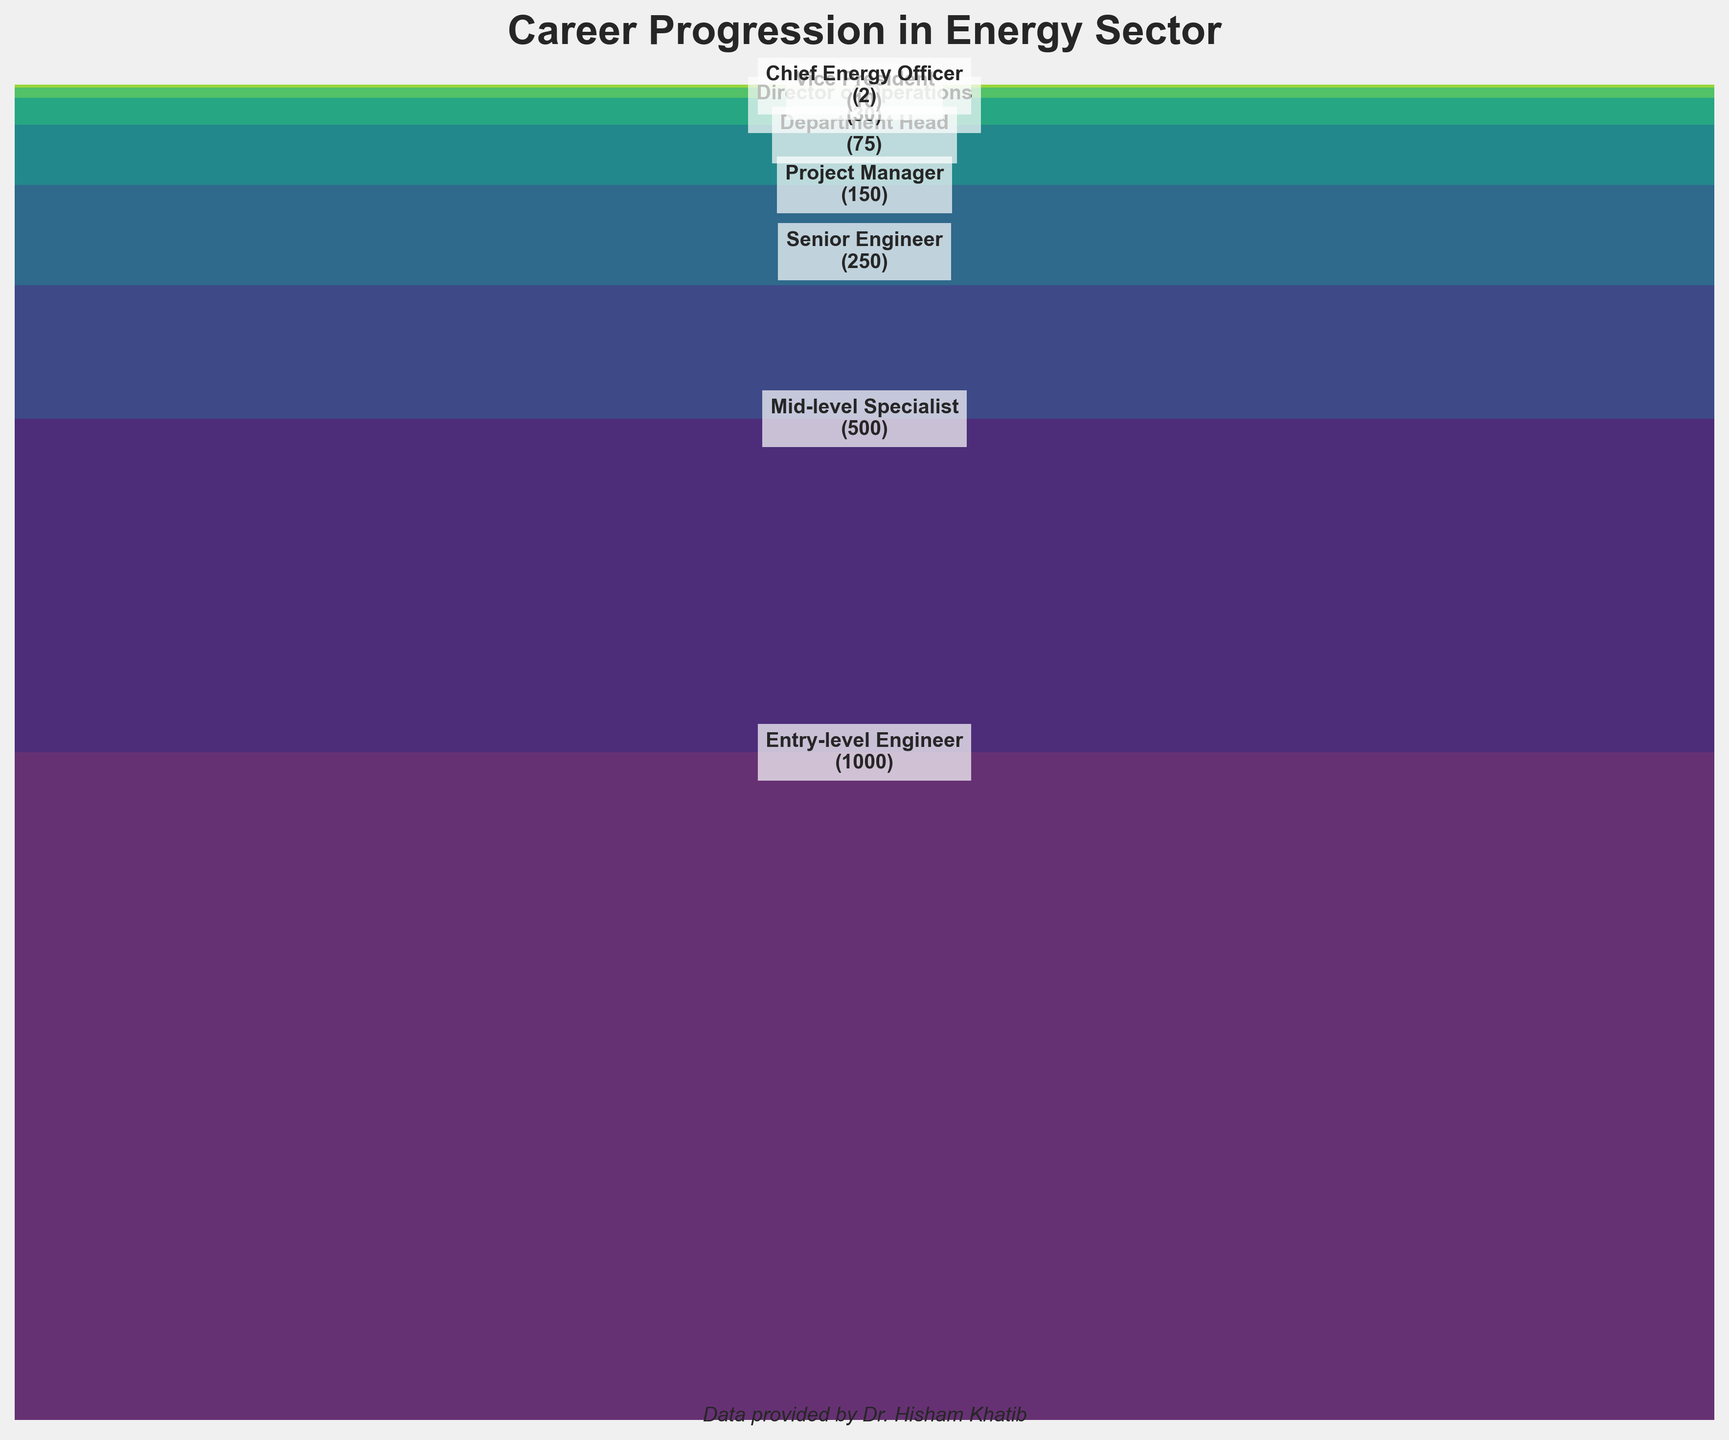What is the title of the figure? The title of the figure is usually placed at the top of the chart and is the most visually prominent text.
Answer: Career Progression in Energy Sector How many stages of career progression are depicted in the figure? By observing the chart, count the number of distinct stages labeled.
Answer: Eight stages Which stage has the highest number of professionals? The highest number of professionals is the widest section at the top of the funnel.
Answer: Entry-level Engineer Which stage comes immediately after "Mid-level Specialist"? Follow the progression from "Mid-level Specialist" to the next labeled stage down the funnel.
Answer: Senior Engineer What is the total number of professionals from the entry-level to project manager stages combined? Add the values from "Entry-level Engineer" to "Project Manager": 1000 + 500 + 250 + 150 = 1900.
Answer: 1900 How many professionals are there at the executive level (Vice President and Chief Energy Officer combined)? Sum the values for "Vice President" and "Chief Energy Officer": 10 + 2 = 12.
Answer: 12 What is the ratio of "Department Head" to "Director of Operations"? Divide the number of "Department Head" by the number of "Director of Operations": 75 / 30 = 2.5.
Answer: 2.5 Which stage has fewer professionals: "Project Manager" or "Department Head"? Compare the values of "Project Manager" and "Department Head": 150 (Project Manager) vs 75 (Department Head).
Answer: Department Head What is the difference in the number of professionals between "Senior Engineer" and "Chief Energy Officer"? Subtract the number of "Chief Energy Officer" from "Senior Engineer": 250 - 2 = 248.
Answer: 248 How does the number of professionals change as one progresses from entry-level to the executive position? Observe the trend in section sizes from top to bottom; they decrease, indicating fewer professionals as you move up.
Answer: Decreases 